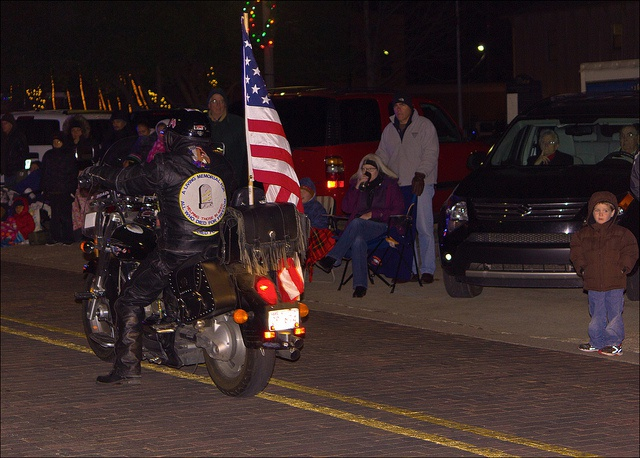Describe the objects in this image and their specific colors. I can see motorcycle in black, maroon, and gray tones, car in black, maroon, and gray tones, people in black and darkgray tones, car in black, maroon, red, and brown tones, and people in black, maroon, and purple tones in this image. 